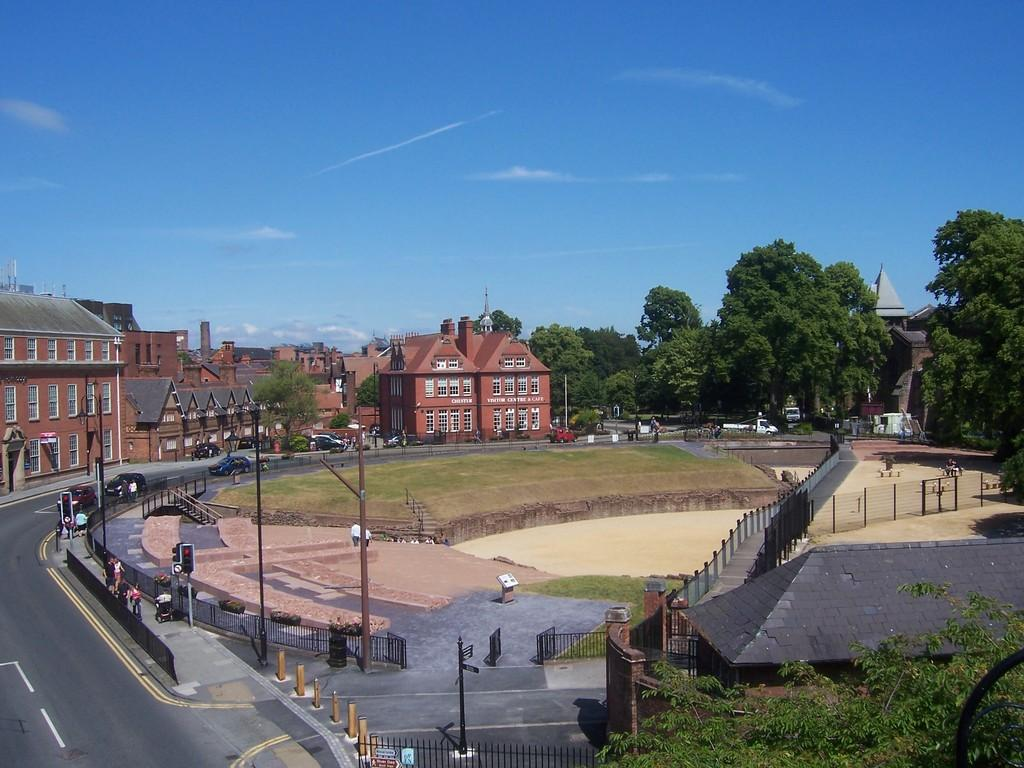What is located in front of the road in the image? There are buildings in front of the road in the image. What type of infrastructure is visible in the image? There are roads in the image. What is happening on the roads in the image? Cars are riding on the road. What type of behavior can be observed in the garden in the image? There is no garden present in the image, so it is not possible to observe any behavior in a garden. How many seats are available for passengers in the cars in the image? The image does not provide enough detail to determine the number of seats in the cars. 